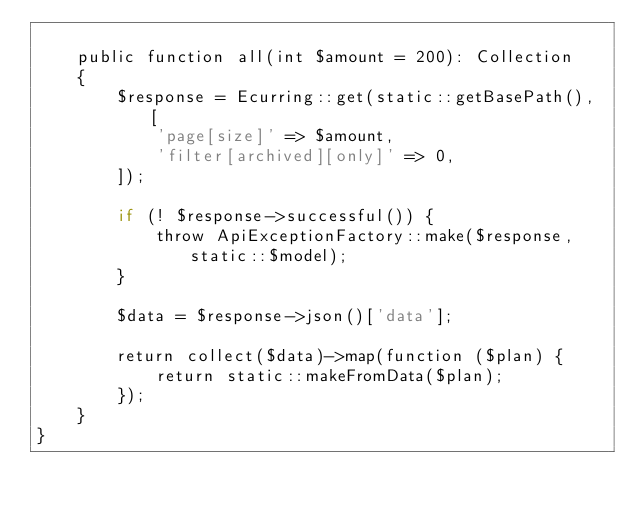<code> <loc_0><loc_0><loc_500><loc_500><_PHP_>
    public function all(int $amount = 200): Collection
    {
        $response = Ecurring::get(static::getBasePath(), [
            'page[size]' => $amount,
            'filter[archived][only]' => 0,
        ]);

        if (! $response->successful()) {
            throw ApiExceptionFactory::make($response, static::$model);
        }

        $data = $response->json()['data'];

        return collect($data)->map(function ($plan) {
            return static::makeFromData($plan);
        });
    }
}
</code> 